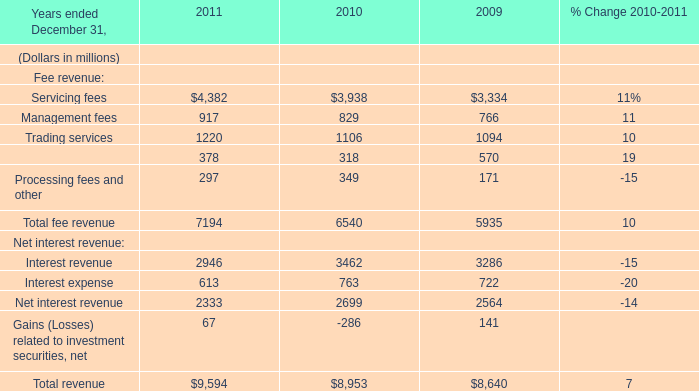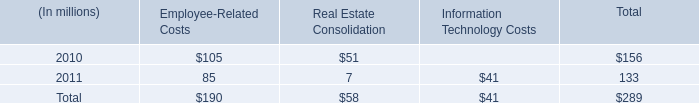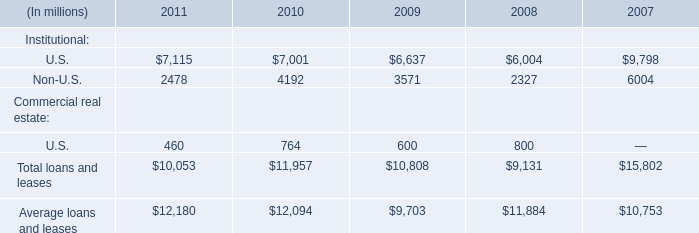What's the current growth rate of securities finance? (in %) 
Computations: ((378 - 318) / 318)
Answer: 0.18868. 